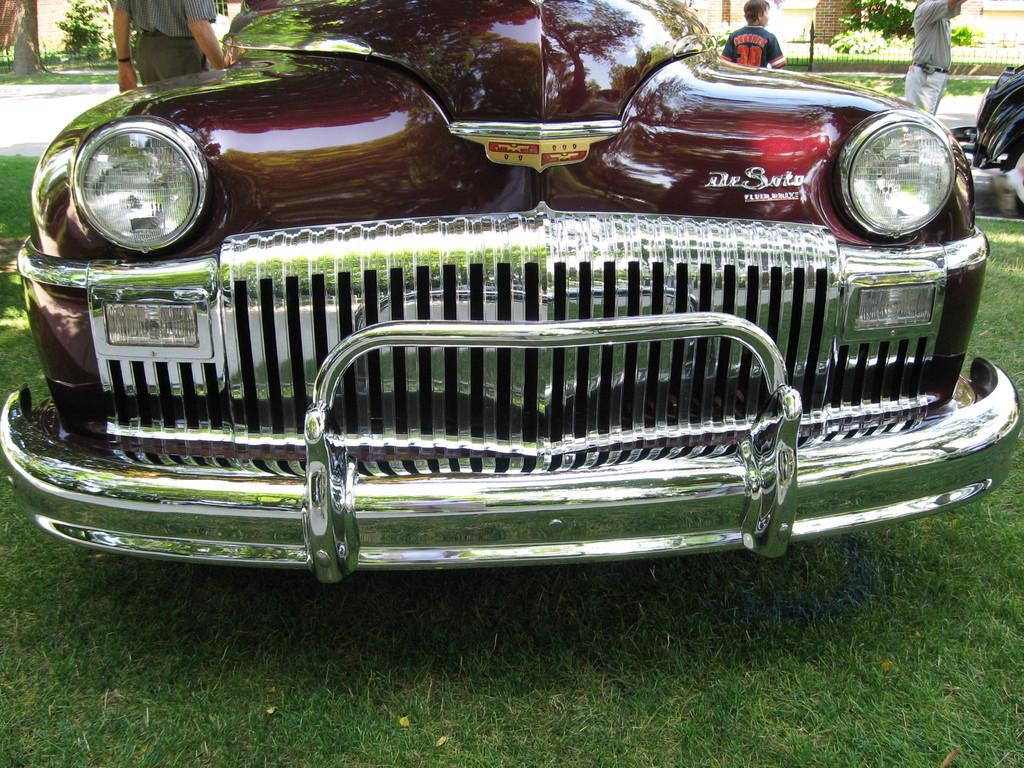What is the main subject of the image? The main subject of the image is a car on the grass. What can be seen in the background of the image? In the background of the image, there are persons, objects, a fence, plants, and a wall. Can you describe the left side of the image? On the left side of the image, there is a tree trunk. How many horses are visible in the image? There are no horses present in the image. What type of furniture can be seen in the image? There is no furniture visible in the image. 